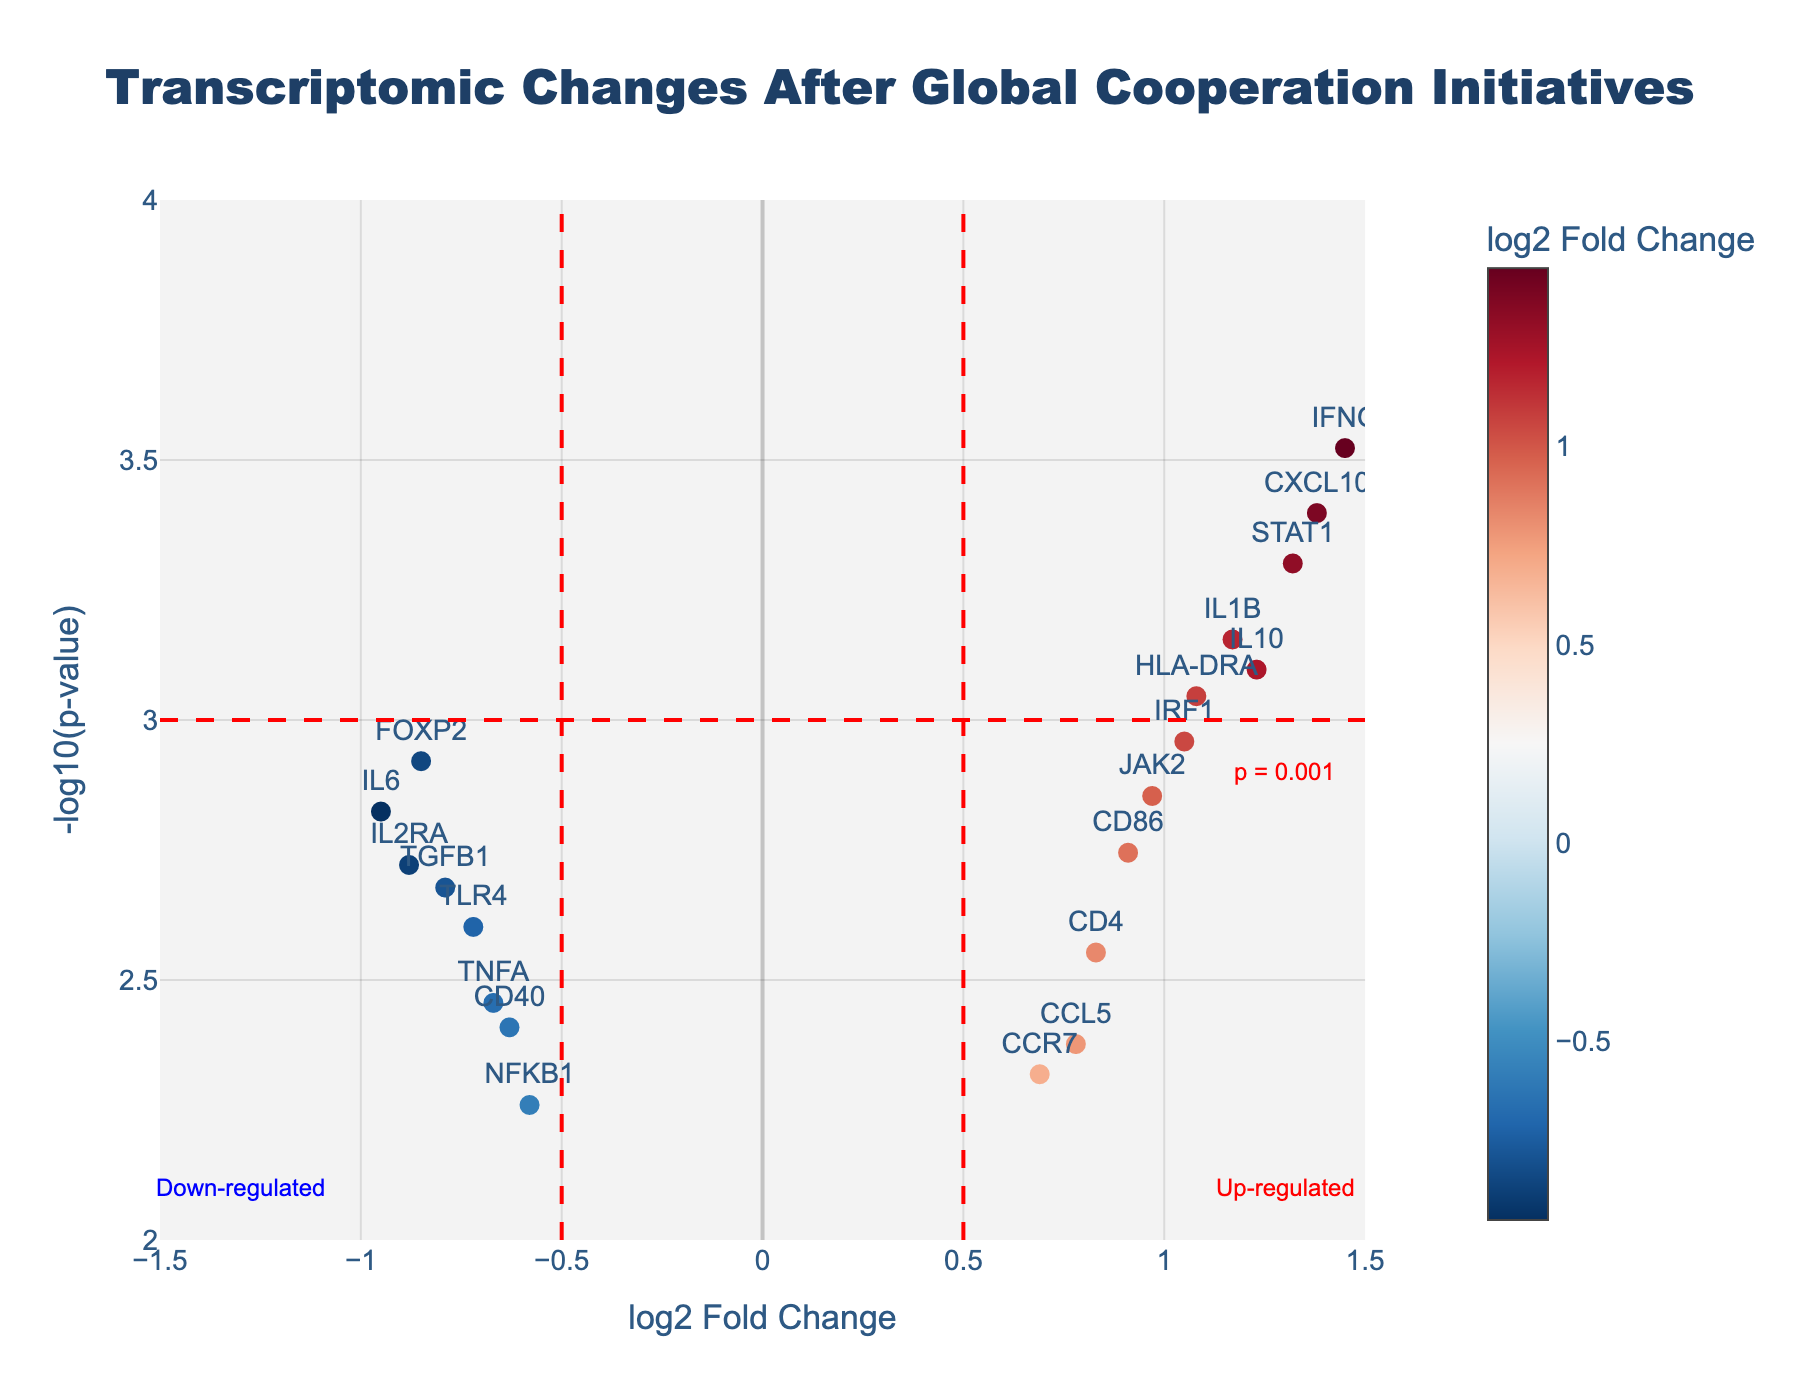What is the title of the plot? The title is located at the top center of the plot, above the data points. It reads: "Transcriptomic Changes After Global Cooperation Initiatives".
Answer: Transcriptomic Changes After Global Cooperation Initiatives How many genes are displayed in the plot? By counting the labels of each gene, there are 20 genes displayed in the plot.
Answer: 20 What does the x-axis represent? The x-axis is labeled "log2 Fold Change", indicating the changes in gene expression on a logarithmic scale.
Answer: log2 Fold Change What does the y-axis represent? The y-axis is labeled "-log10(p-value)", which shows the statistical significance of the gene expression changes.
Answer: -log10(p-value) Which gene has the highest statistical significance? The gene with the highest statistical significance will have the highest value on the y-axis (-log10(p-value)). This is the gene IFNG.
Answer: IFNG Which gene is the most up-regulated? The most up-regulated gene will have the highest log2 Fold Change value on the x-axis. Looking at the plot, the gene CXCL10 has the highest log2 Fold Change value.
Answer: CXCL10 How many genes are significantly up-regulated? Genes that are significantly up-regulated will have a log2 Fold Change value greater than 0.5 and a p-value less than 0.001 (horizontal and vertical red lines). By looking at the plot, there are 5 up-regulated genes: IL10, CD86, IFNG, STAT1, and CXCL10.
Answer: 5 Which gene is located closest to the origin? The origin is at (0, 0), so the closest gene should have its values near zero on both axes. The gene TLR4 appears to be the closest to the origin.
Answer: TLR4 Which gene shows the greatest down-regulation? The most down-regulated gene will have the lowest log2 Fold Change value on the x-axis. In the plot, the gene IL6 has the lowest log2 Fold Change value.
Answer: IL6 Is there any gene with a log2 Fold Change close to zero and a high statistical significance? Genes with log2 Fold Change close to zero and high statistical significance will appear near the origin on the x-axis but have high values on the y-axis. The genes JAK2 and CD4 are examples of this, with log2 Fold Changes near zero and high -log10(p-value).
Answer: JAK2 and CD4 